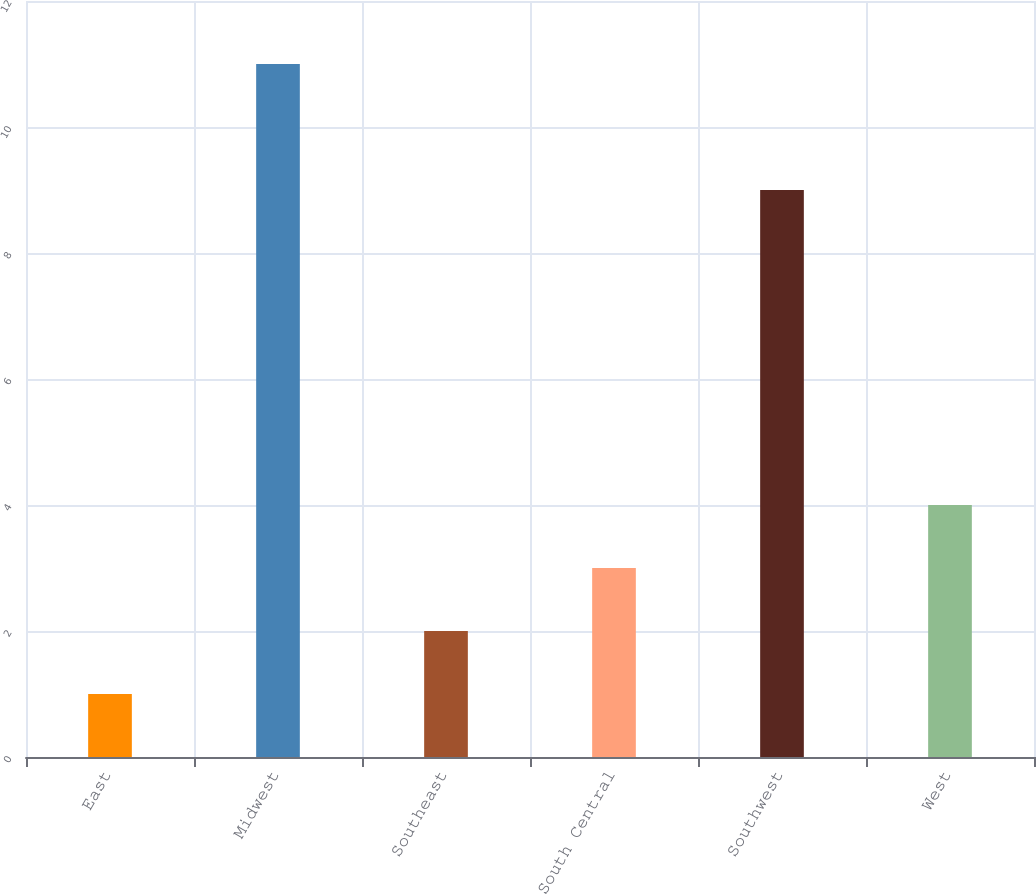<chart> <loc_0><loc_0><loc_500><loc_500><bar_chart><fcel>East<fcel>Midwest<fcel>Southeast<fcel>South Central<fcel>Southwest<fcel>West<nl><fcel>1<fcel>11<fcel>2<fcel>3<fcel>9<fcel>4<nl></chart> 